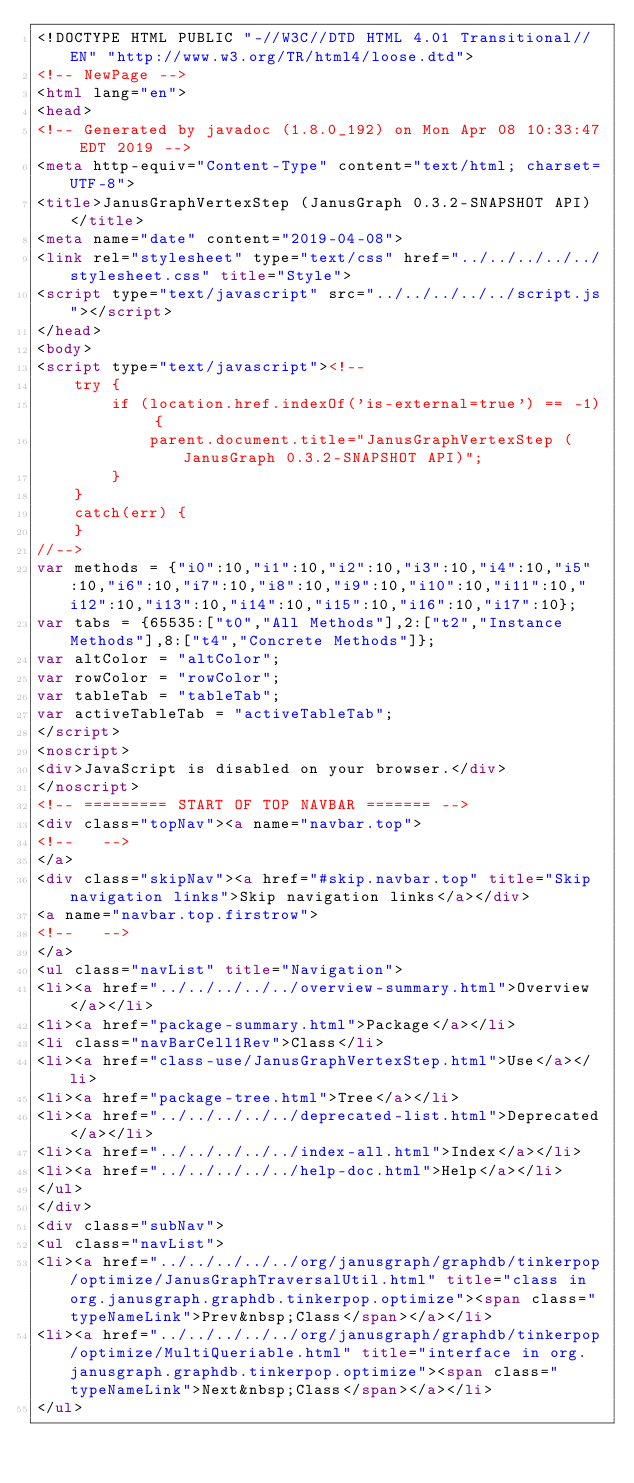<code> <loc_0><loc_0><loc_500><loc_500><_HTML_><!DOCTYPE HTML PUBLIC "-//W3C//DTD HTML 4.01 Transitional//EN" "http://www.w3.org/TR/html4/loose.dtd">
<!-- NewPage -->
<html lang="en">
<head>
<!-- Generated by javadoc (1.8.0_192) on Mon Apr 08 10:33:47 EDT 2019 -->
<meta http-equiv="Content-Type" content="text/html; charset=UTF-8">
<title>JanusGraphVertexStep (JanusGraph 0.3.2-SNAPSHOT API)</title>
<meta name="date" content="2019-04-08">
<link rel="stylesheet" type="text/css" href="../../../../../stylesheet.css" title="Style">
<script type="text/javascript" src="../../../../../script.js"></script>
</head>
<body>
<script type="text/javascript"><!--
    try {
        if (location.href.indexOf('is-external=true') == -1) {
            parent.document.title="JanusGraphVertexStep (JanusGraph 0.3.2-SNAPSHOT API)";
        }
    }
    catch(err) {
    }
//-->
var methods = {"i0":10,"i1":10,"i2":10,"i3":10,"i4":10,"i5":10,"i6":10,"i7":10,"i8":10,"i9":10,"i10":10,"i11":10,"i12":10,"i13":10,"i14":10,"i15":10,"i16":10,"i17":10};
var tabs = {65535:["t0","All Methods"],2:["t2","Instance Methods"],8:["t4","Concrete Methods"]};
var altColor = "altColor";
var rowColor = "rowColor";
var tableTab = "tableTab";
var activeTableTab = "activeTableTab";
</script>
<noscript>
<div>JavaScript is disabled on your browser.</div>
</noscript>
<!-- ========= START OF TOP NAVBAR ======= -->
<div class="topNav"><a name="navbar.top">
<!--   -->
</a>
<div class="skipNav"><a href="#skip.navbar.top" title="Skip navigation links">Skip navigation links</a></div>
<a name="navbar.top.firstrow">
<!--   -->
</a>
<ul class="navList" title="Navigation">
<li><a href="../../../../../overview-summary.html">Overview</a></li>
<li><a href="package-summary.html">Package</a></li>
<li class="navBarCell1Rev">Class</li>
<li><a href="class-use/JanusGraphVertexStep.html">Use</a></li>
<li><a href="package-tree.html">Tree</a></li>
<li><a href="../../../../../deprecated-list.html">Deprecated</a></li>
<li><a href="../../../../../index-all.html">Index</a></li>
<li><a href="../../../../../help-doc.html">Help</a></li>
</ul>
</div>
<div class="subNav">
<ul class="navList">
<li><a href="../../../../../org/janusgraph/graphdb/tinkerpop/optimize/JanusGraphTraversalUtil.html" title="class in org.janusgraph.graphdb.tinkerpop.optimize"><span class="typeNameLink">Prev&nbsp;Class</span></a></li>
<li><a href="../../../../../org/janusgraph/graphdb/tinkerpop/optimize/MultiQueriable.html" title="interface in org.janusgraph.graphdb.tinkerpop.optimize"><span class="typeNameLink">Next&nbsp;Class</span></a></li>
</ul></code> 